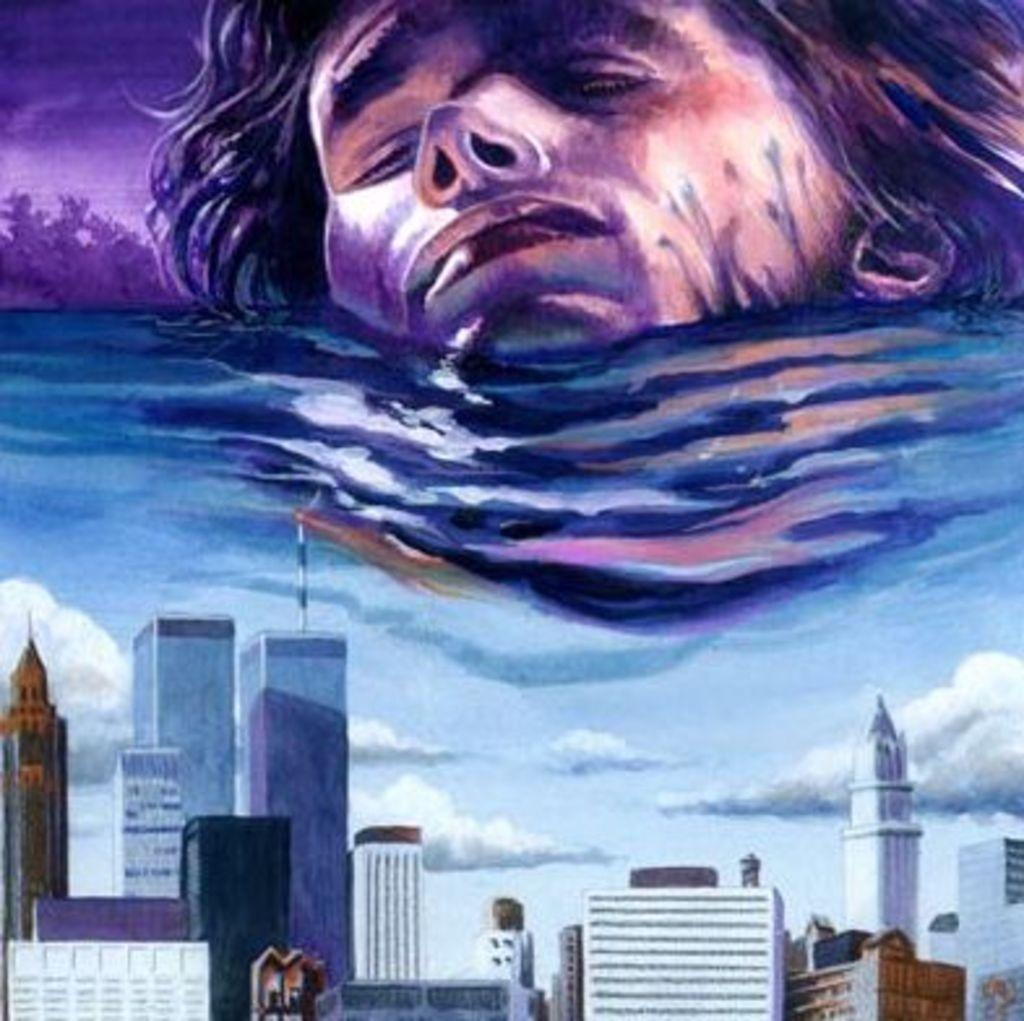What type of artwork is depicted in the image? The image is a painting. What structures can be seen in the painting? There are buildings in the painting. What is visible in the sky in the painting? There are clouds in the sky in the painting. What natural element is present in the painting? There is water visible in the painting. What other objects are present in the painting? There are other objects in the painting. Can you identify any human features in the painting? The head of a person is present in the painting. What type of plant is growing in the painting? There is no plant visible in the painting; it features buildings, clouds, water, and other objects. How many screws can be seen holding the buildings together in the painting? There are no screws present in the painting; it is a painting of buildings, clouds, water, and other objects. 